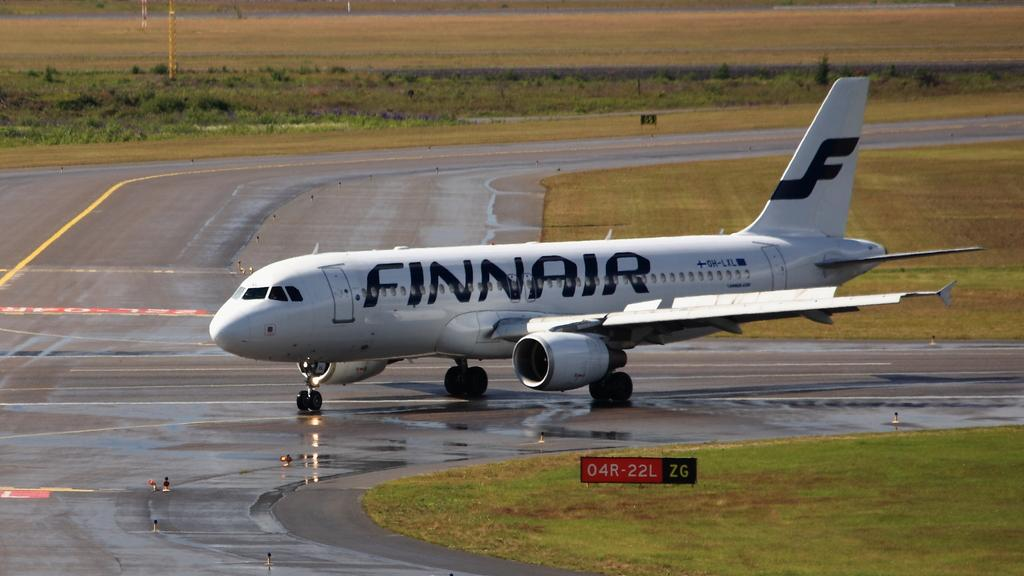<image>
Relay a brief, clear account of the picture shown. An airplane from the airline Finnair on the runway 